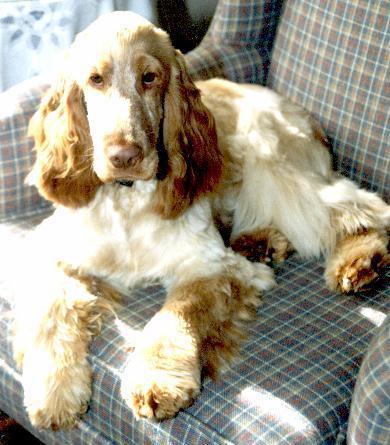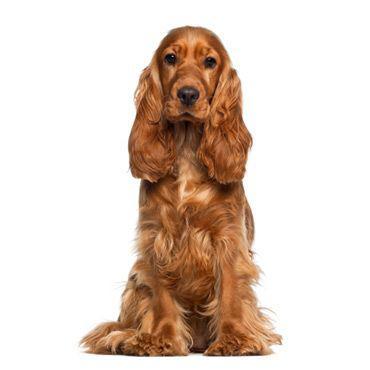The first image is the image on the left, the second image is the image on the right. For the images shown, is this caption "At least one of the images shows a Cocker Spaniel with their tongue out." true? Answer yes or no. No. The first image is the image on the left, the second image is the image on the right. Given the left and right images, does the statement "The combined images include one dog reclining with front paws extended and one dog with red-orange fur sitting upright." hold true? Answer yes or no. Yes. 